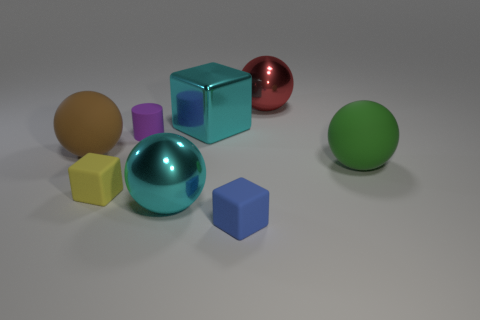Subtract all large cyan shiny balls. How many balls are left? 3 Subtract all green spheres. How many spheres are left? 3 Add 1 large blocks. How many objects exist? 9 Subtract 1 blocks. How many blocks are left? 2 Subtract all cylinders. How many objects are left? 7 Add 8 red metallic spheres. How many red metallic spheres are left? 9 Add 8 purple shiny balls. How many purple shiny balls exist? 8 Subtract 0 purple spheres. How many objects are left? 8 Subtract all purple blocks. Subtract all blue cylinders. How many blocks are left? 3 Subtract all big things. Subtract all shiny spheres. How many objects are left? 1 